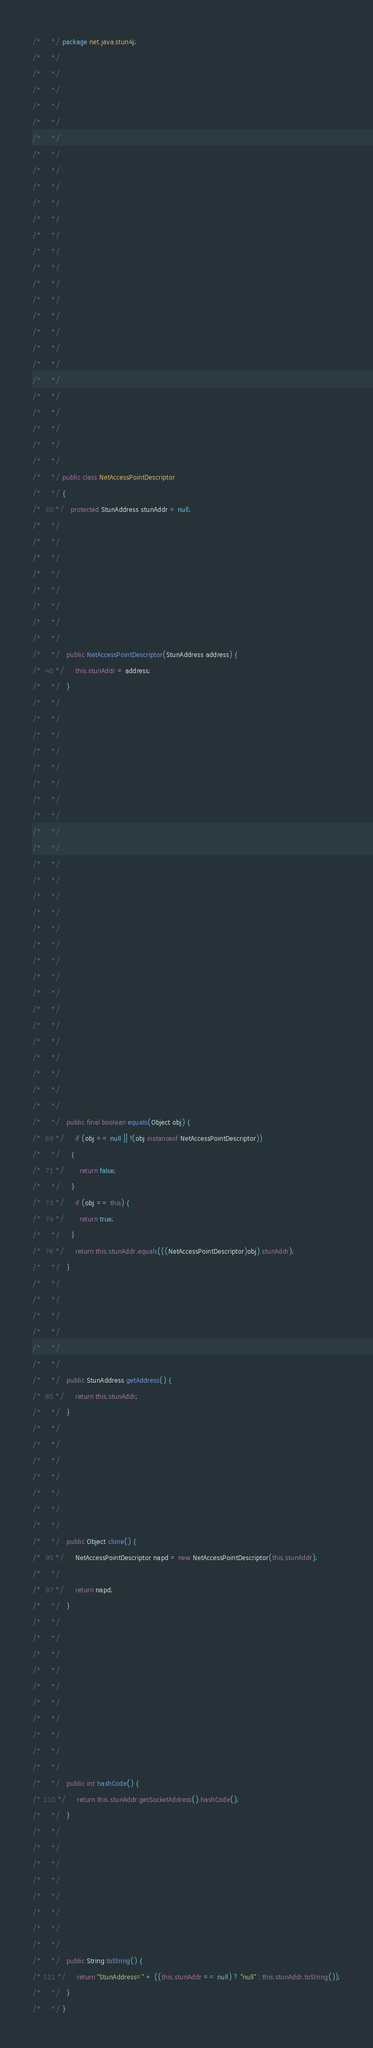Convert code to text. <code><loc_0><loc_0><loc_500><loc_500><_Java_>/*     */ package net.java.stun4j;
/*     */ 
/*     */ 
/*     */ 
/*     */ 
/*     */ 
/*     */ 
/*     */ 
/*     */ 
/*     */ 
/*     */ 
/*     */ 
/*     */ 
/*     */ 
/*     */ 
/*     */ 
/*     */ 
/*     */ 
/*     */ 
/*     */ 
/*     */ 
/*     */ 
/*     */ 
/*     */ 
/*     */ 
/*     */ 
/*     */ 
/*     */ public class NetAccessPointDescriptor
/*     */ {
/*  30 */   protected StunAddress stunAddr = null;
/*     */ 
/*     */ 
/*     */ 
/*     */ 
/*     */ 
/*     */ 
/*     */ 
/*     */   
/*     */   public NetAccessPointDescriptor(StunAddress address) {
/*  40 */     this.stunAddr = address;
/*     */   }
/*     */ 
/*     */ 
/*     */ 
/*     */ 
/*     */ 
/*     */ 
/*     */ 
/*     */ 
/*     */ 
/*     */ 
/*     */ 
/*     */ 
/*     */ 
/*     */ 
/*     */ 
/*     */ 
/*     */ 
/*     */ 
/*     */ 
/*     */ 
/*     */ 
/*     */ 
/*     */ 
/*     */ 
/*     */ 
/*     */   
/*     */   public final boolean equals(Object obj) {
/*  69 */     if (obj == null || !(obj instanceof NetAccessPointDescriptor))
/*     */     {
/*  71 */       return false;
/*     */     }
/*  73 */     if (obj == this) {
/*  74 */       return true;
/*     */     }
/*  76 */     return this.stunAddr.equals(((NetAccessPointDescriptor)obj).stunAddr);
/*     */   }
/*     */ 
/*     */ 
/*     */ 
/*     */ 
/*     */ 
/*     */   
/*     */   public StunAddress getAddress() {
/*  85 */     return this.stunAddr;
/*     */   }
/*     */ 
/*     */ 
/*     */ 
/*     */ 
/*     */ 
/*     */ 
/*     */   
/*     */   public Object clone() {
/*  95 */     NetAccessPointDescriptor napd = new NetAccessPointDescriptor(this.stunAddr);
/*     */     
/*  97 */     return napd;
/*     */   }
/*     */ 
/*     */ 
/*     */ 
/*     */ 
/*     */ 
/*     */ 
/*     */ 
/*     */ 
/*     */ 
/*     */   
/*     */   public int hashCode() {
/* 110 */     return this.stunAddr.getSocketAddress().hashCode();
/*     */   }
/*     */ 
/*     */ 
/*     */ 
/*     */ 
/*     */ 
/*     */ 
/*     */ 
/*     */   
/*     */   public String toString() {
/* 121 */     return "StunAddress=" + ((this.stunAddr == null) ? "null" : this.stunAddr.toString());
/*     */   }
/*     */ }
</code> 